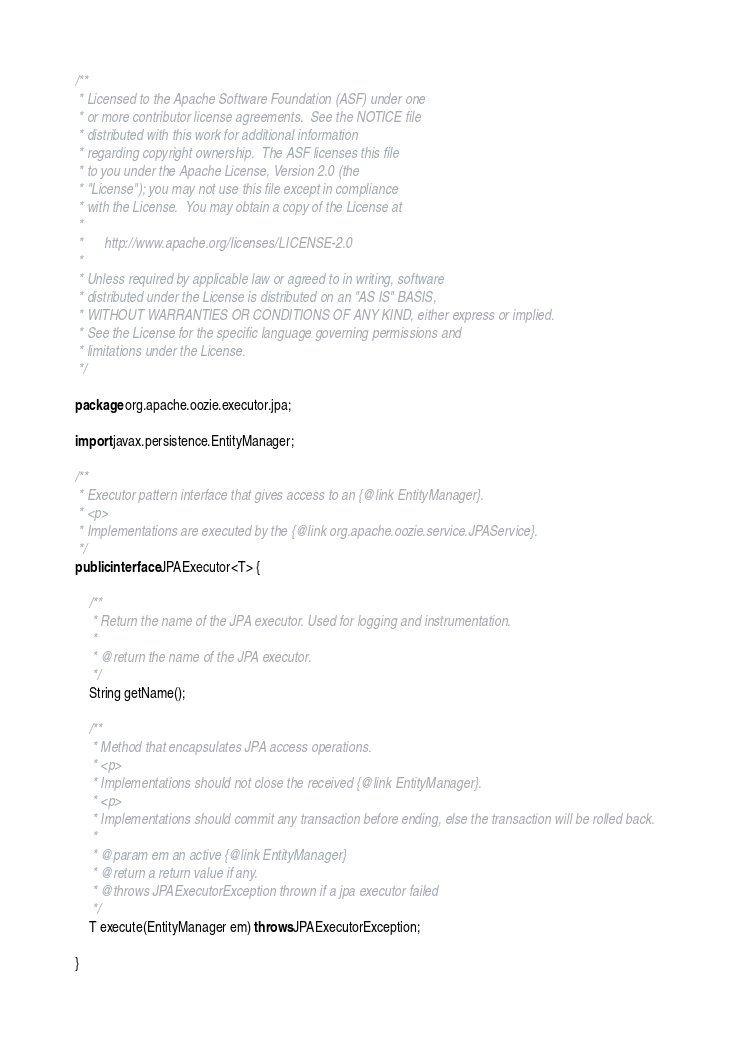Convert code to text. <code><loc_0><loc_0><loc_500><loc_500><_Java_>/**
 * Licensed to the Apache Software Foundation (ASF) under one
 * or more contributor license agreements.  See the NOTICE file
 * distributed with this work for additional information
 * regarding copyright ownership.  The ASF licenses this file
 * to you under the Apache License, Version 2.0 (the
 * "License"); you may not use this file except in compliance
 * with the License.  You may obtain a copy of the License at
 *
 *      http://www.apache.org/licenses/LICENSE-2.0
 *
 * Unless required by applicable law or agreed to in writing, software
 * distributed under the License is distributed on an "AS IS" BASIS,
 * WITHOUT WARRANTIES OR CONDITIONS OF ANY KIND, either express or implied.
 * See the License for the specific language governing permissions and
 * limitations under the License.
 */

package org.apache.oozie.executor.jpa;

import javax.persistence.EntityManager;

/**
 * Executor pattern interface that gives access to an {@link EntityManager}.
 * <p>
 * Implementations are executed by the {@link org.apache.oozie.service.JPAService}.
 */
public interface JPAExecutor<T> {

    /**
     * Return the name of the JPA executor. Used for logging and instrumentation.
     *
     * @return the name of the JPA executor.
     */
    String getName();

    /**
     * Method that encapsulates JPA access operations.
     * <p>
     * Implementations should not close the received {@link EntityManager}.
     * <p>
     * Implementations should commit any transaction before ending, else the transaction will be rolled back.
     *
     * @param em an active {@link EntityManager}
     * @return a return value if any.
     * @throws JPAExecutorException thrown if a jpa executor failed
     */
    T execute(EntityManager em) throws JPAExecutorException;

}
</code> 